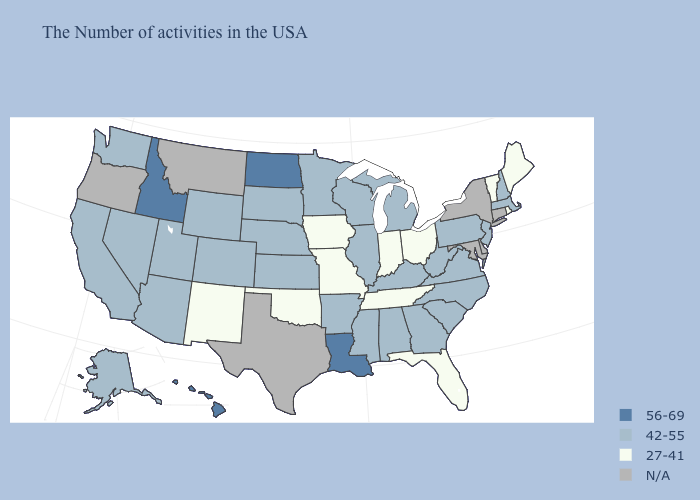Name the states that have a value in the range 42-55?
Keep it brief. Massachusetts, New Hampshire, New Jersey, Pennsylvania, Virginia, North Carolina, South Carolina, West Virginia, Georgia, Michigan, Kentucky, Alabama, Wisconsin, Illinois, Mississippi, Arkansas, Minnesota, Kansas, Nebraska, South Dakota, Wyoming, Colorado, Utah, Arizona, Nevada, California, Washington, Alaska. Name the states that have a value in the range 42-55?
Keep it brief. Massachusetts, New Hampshire, New Jersey, Pennsylvania, Virginia, North Carolina, South Carolina, West Virginia, Georgia, Michigan, Kentucky, Alabama, Wisconsin, Illinois, Mississippi, Arkansas, Minnesota, Kansas, Nebraska, South Dakota, Wyoming, Colorado, Utah, Arizona, Nevada, California, Washington, Alaska. Name the states that have a value in the range 42-55?
Concise answer only. Massachusetts, New Hampshire, New Jersey, Pennsylvania, Virginia, North Carolina, South Carolina, West Virginia, Georgia, Michigan, Kentucky, Alabama, Wisconsin, Illinois, Mississippi, Arkansas, Minnesota, Kansas, Nebraska, South Dakota, Wyoming, Colorado, Utah, Arizona, Nevada, California, Washington, Alaska. Name the states that have a value in the range 56-69?
Answer briefly. Louisiana, North Dakota, Idaho, Hawaii. Among the states that border Ohio , does West Virginia have the highest value?
Give a very brief answer. Yes. Name the states that have a value in the range N/A?
Keep it brief. Connecticut, New York, Delaware, Maryland, Texas, Montana, Oregon. What is the value of South Carolina?
Concise answer only. 42-55. What is the value of Kansas?
Write a very short answer. 42-55. Does New Jersey have the lowest value in the USA?
Concise answer only. No. Does the first symbol in the legend represent the smallest category?
Keep it brief. No. Is the legend a continuous bar?
Keep it brief. No. What is the highest value in states that border New Mexico?
Concise answer only. 42-55. What is the lowest value in the USA?
Be succinct. 27-41. Does Pennsylvania have the lowest value in the Northeast?
Write a very short answer. No. 